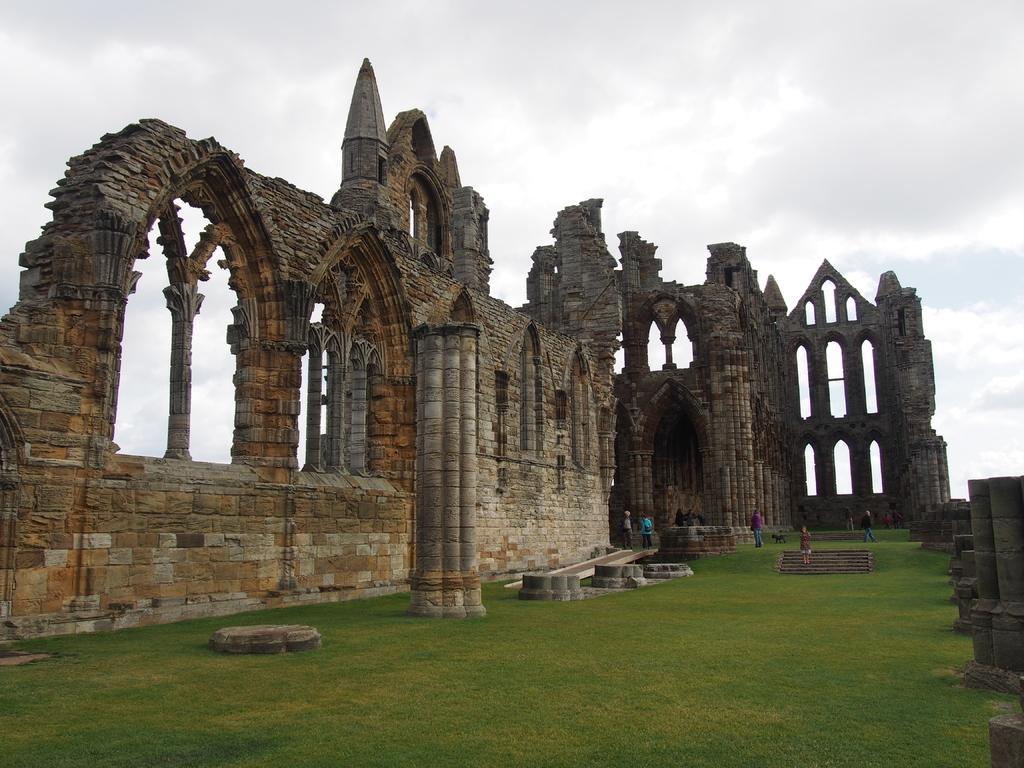Please provide a concise description of this image. n the picture I can see a greenery ground and there are few people standing and there is a Whitby Abbey beside them and the sky is cloudy. 